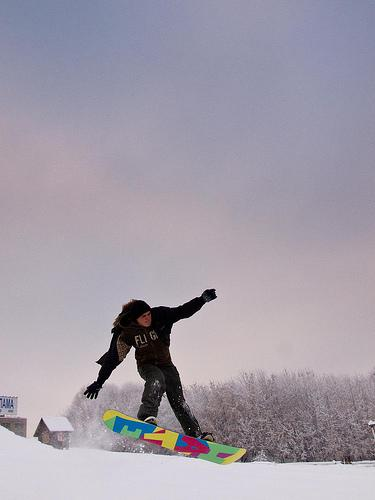Question: what activity is being performed in this picture?
Choices:
A. Snowboarding.
B. Rollerblading.
C. Bowling.
D. Shuffleboard.
Answer with the letter. Answer: A 